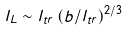Convert formula to latex. <formula><loc_0><loc_0><loc_500><loc_500>l _ { L } \sim l _ { t r } \left ( b / l _ { t r } \right ) ^ { 2 / 3 }</formula> 